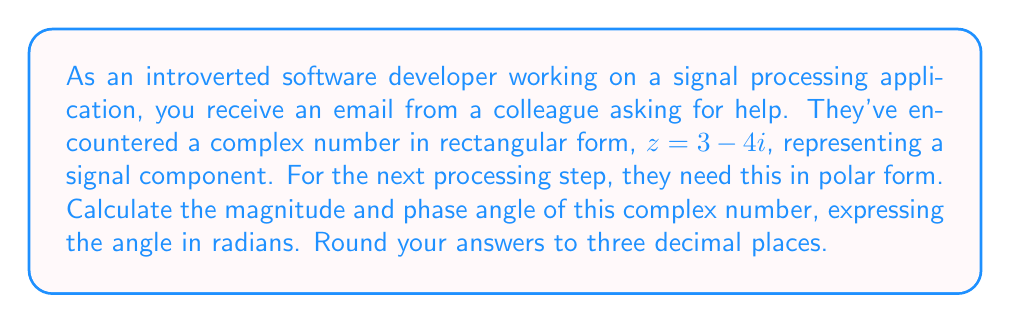Can you solve this math problem? To convert a complex number from rectangular form $(a + bi)$ to polar form $(r \angle \theta)$, we need to calculate the magnitude $r$ and the phase angle $\theta$.

1. Calculate the magnitude $r$:
   $$r = \sqrt{a^2 + b^2}$$
   In this case, $a = 3$ and $b = -4$
   $$r = \sqrt{3^2 + (-4)^2} = \sqrt{9 + 16} = \sqrt{25} = 5$$

2. Calculate the phase angle $\theta$:
   $$\theta = \tan^{-1}\left(\frac{b}{a}\right)$$
   However, we need to be careful here. Since $a$ is positive and $b$ is negative, we're in the fourth quadrant. We need to add $2\pi$ to the result of $\tan^{-1}$ to get the correct angle in the range $[0, 2\pi)$.
   
   $$\theta = \tan^{-1}\left(\frac{-4}{3}\right) + 2\pi$$
   
   $$\theta = -0.927 + 2\pi \approx 5.356 \text{ radians}$$

Rounding both results to three decimal places:
Magnitude $r = 5.000$
Phase angle $\theta = 5.356$ radians
Answer: $5.000 \angle 5.356$ 